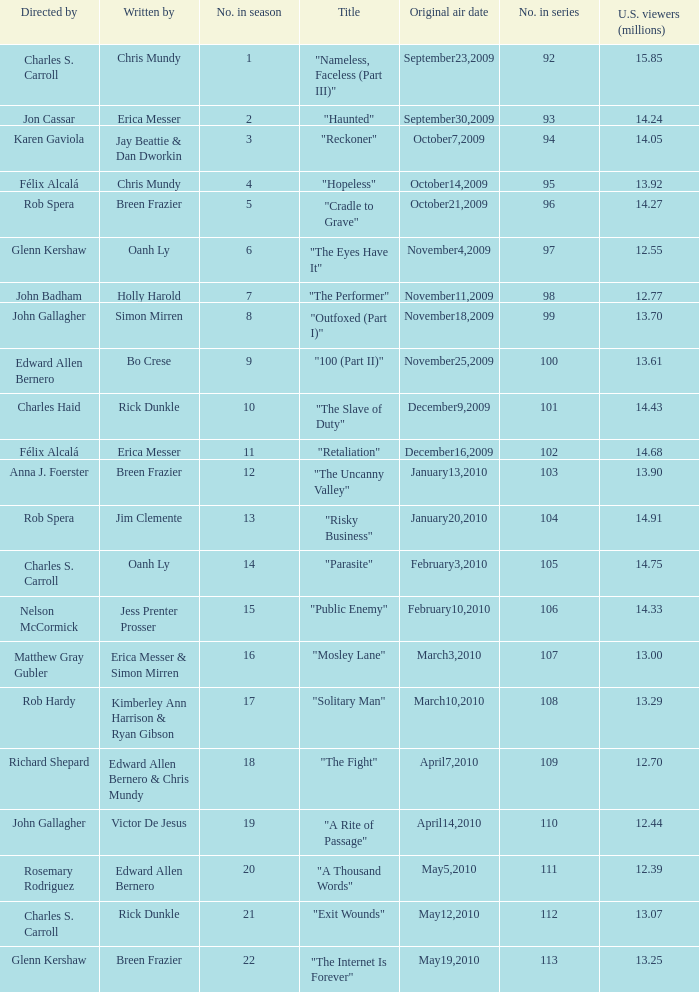What number(s) in the series was written by bo crese? 100.0. 